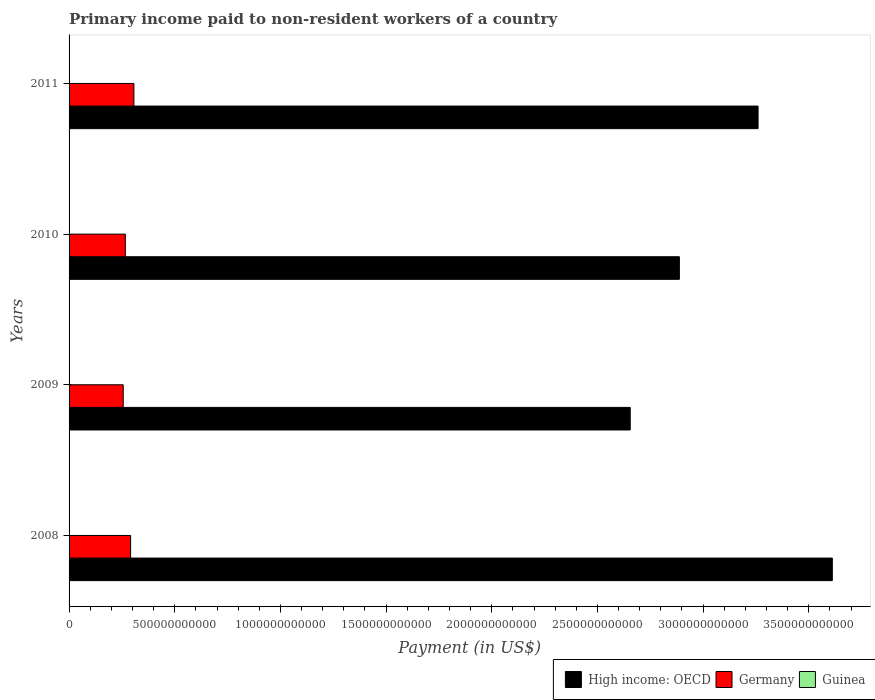How many different coloured bars are there?
Offer a very short reply. 3. How many groups of bars are there?
Offer a terse response. 4. Are the number of bars on each tick of the Y-axis equal?
Your answer should be compact. Yes. What is the label of the 3rd group of bars from the top?
Keep it short and to the point. 2009. What is the amount paid to workers in High income: OECD in 2009?
Your answer should be very brief. 2.66e+12. Across all years, what is the maximum amount paid to workers in High income: OECD?
Your response must be concise. 3.61e+12. Across all years, what is the minimum amount paid to workers in Germany?
Your answer should be very brief. 2.56e+11. What is the total amount paid to workers in Germany in the graph?
Provide a short and direct response. 1.12e+12. What is the difference between the amount paid to workers in Germany in 2010 and that in 2011?
Your answer should be very brief. -4.06e+1. What is the difference between the amount paid to workers in Guinea in 2009 and the amount paid to workers in Germany in 2011?
Make the answer very short. -3.07e+11. What is the average amount paid to workers in Guinea per year?
Your answer should be very brief. 1.73e+07. In the year 2008, what is the difference between the amount paid to workers in Germany and amount paid to workers in High income: OECD?
Offer a very short reply. -3.32e+12. In how many years, is the amount paid to workers in Germany greater than 300000000000 US$?
Offer a terse response. 1. What is the ratio of the amount paid to workers in Guinea in 2008 to that in 2010?
Your answer should be compact. 0.66. Is the amount paid to workers in High income: OECD in 2008 less than that in 2010?
Give a very brief answer. No. What is the difference between the highest and the second highest amount paid to workers in Germany?
Your answer should be very brief. 1.56e+1. What is the difference between the highest and the lowest amount paid to workers in Guinea?
Offer a very short reply. 1.24e+07. Is the sum of the amount paid to workers in Guinea in 2010 and 2011 greater than the maximum amount paid to workers in Germany across all years?
Offer a terse response. No. What does the 1st bar from the top in 2011 represents?
Provide a succinct answer. Guinea. What does the 3rd bar from the bottom in 2010 represents?
Ensure brevity in your answer.  Guinea. Is it the case that in every year, the sum of the amount paid to workers in Germany and amount paid to workers in High income: OECD is greater than the amount paid to workers in Guinea?
Provide a succinct answer. Yes. How many years are there in the graph?
Provide a succinct answer. 4. What is the difference between two consecutive major ticks on the X-axis?
Make the answer very short. 5.00e+11. Are the values on the major ticks of X-axis written in scientific E-notation?
Keep it short and to the point. No. Does the graph contain any zero values?
Offer a terse response. No. Where does the legend appear in the graph?
Provide a succinct answer. Bottom right. How many legend labels are there?
Provide a succinct answer. 3. How are the legend labels stacked?
Your response must be concise. Horizontal. What is the title of the graph?
Offer a terse response. Primary income paid to non-resident workers of a country. What is the label or title of the X-axis?
Provide a succinct answer. Payment (in US$). What is the Payment (in US$) of High income: OECD in 2008?
Provide a short and direct response. 3.61e+12. What is the Payment (in US$) in Germany in 2008?
Your response must be concise. 2.91e+11. What is the Payment (in US$) of Guinea in 2008?
Offer a terse response. 9.85e+06. What is the Payment (in US$) of High income: OECD in 2009?
Provide a succinct answer. 2.66e+12. What is the Payment (in US$) in Germany in 2009?
Make the answer very short. 2.56e+11. What is the Payment (in US$) in Guinea in 2009?
Keep it short and to the point. 2.22e+07. What is the Payment (in US$) of High income: OECD in 2010?
Provide a short and direct response. 2.89e+12. What is the Payment (in US$) in Germany in 2010?
Provide a short and direct response. 2.66e+11. What is the Payment (in US$) of Guinea in 2010?
Provide a short and direct response. 1.49e+07. What is the Payment (in US$) in High income: OECD in 2011?
Make the answer very short. 3.26e+12. What is the Payment (in US$) of Germany in 2011?
Your answer should be compact. 3.07e+11. What is the Payment (in US$) of Guinea in 2011?
Your answer should be compact. 2.22e+07. Across all years, what is the maximum Payment (in US$) of High income: OECD?
Offer a very short reply. 3.61e+12. Across all years, what is the maximum Payment (in US$) of Germany?
Provide a succinct answer. 3.07e+11. Across all years, what is the maximum Payment (in US$) of Guinea?
Your answer should be very brief. 2.22e+07. Across all years, what is the minimum Payment (in US$) in High income: OECD?
Make the answer very short. 2.66e+12. Across all years, what is the minimum Payment (in US$) of Germany?
Offer a terse response. 2.56e+11. Across all years, what is the minimum Payment (in US$) of Guinea?
Keep it short and to the point. 9.85e+06. What is the total Payment (in US$) of High income: OECD in the graph?
Provide a succinct answer. 1.24e+13. What is the total Payment (in US$) of Germany in the graph?
Your response must be concise. 1.12e+12. What is the total Payment (in US$) in Guinea in the graph?
Make the answer very short. 6.92e+07. What is the difference between the Payment (in US$) in High income: OECD in 2008 and that in 2009?
Your response must be concise. 9.56e+11. What is the difference between the Payment (in US$) of Germany in 2008 and that in 2009?
Your answer should be very brief. 3.49e+1. What is the difference between the Payment (in US$) of Guinea in 2008 and that in 2009?
Ensure brevity in your answer.  -1.23e+07. What is the difference between the Payment (in US$) of High income: OECD in 2008 and that in 2010?
Give a very brief answer. 7.24e+11. What is the difference between the Payment (in US$) in Germany in 2008 and that in 2010?
Keep it short and to the point. 2.49e+1. What is the difference between the Payment (in US$) of Guinea in 2008 and that in 2010?
Offer a very short reply. -5.08e+06. What is the difference between the Payment (in US$) of High income: OECD in 2008 and that in 2011?
Your answer should be compact. 3.51e+11. What is the difference between the Payment (in US$) in Germany in 2008 and that in 2011?
Offer a terse response. -1.56e+1. What is the difference between the Payment (in US$) of Guinea in 2008 and that in 2011?
Provide a succinct answer. -1.24e+07. What is the difference between the Payment (in US$) of High income: OECD in 2009 and that in 2010?
Your answer should be compact. -2.33e+11. What is the difference between the Payment (in US$) of Germany in 2009 and that in 2010?
Offer a terse response. -9.98e+09. What is the difference between the Payment (in US$) in Guinea in 2009 and that in 2010?
Ensure brevity in your answer.  7.24e+06. What is the difference between the Payment (in US$) in High income: OECD in 2009 and that in 2011?
Your answer should be very brief. -6.05e+11. What is the difference between the Payment (in US$) in Germany in 2009 and that in 2011?
Provide a short and direct response. -5.06e+1. What is the difference between the Payment (in US$) in High income: OECD in 2010 and that in 2011?
Your response must be concise. -3.72e+11. What is the difference between the Payment (in US$) of Germany in 2010 and that in 2011?
Keep it short and to the point. -4.06e+1. What is the difference between the Payment (in US$) in Guinea in 2010 and that in 2011?
Your response must be concise. -7.31e+06. What is the difference between the Payment (in US$) in High income: OECD in 2008 and the Payment (in US$) in Germany in 2009?
Offer a very short reply. 3.36e+12. What is the difference between the Payment (in US$) of High income: OECD in 2008 and the Payment (in US$) of Guinea in 2009?
Your answer should be compact. 3.61e+12. What is the difference between the Payment (in US$) of Germany in 2008 and the Payment (in US$) of Guinea in 2009?
Offer a terse response. 2.91e+11. What is the difference between the Payment (in US$) of High income: OECD in 2008 and the Payment (in US$) of Germany in 2010?
Your answer should be very brief. 3.35e+12. What is the difference between the Payment (in US$) of High income: OECD in 2008 and the Payment (in US$) of Guinea in 2010?
Provide a short and direct response. 3.61e+12. What is the difference between the Payment (in US$) of Germany in 2008 and the Payment (in US$) of Guinea in 2010?
Offer a very short reply. 2.91e+11. What is the difference between the Payment (in US$) in High income: OECD in 2008 and the Payment (in US$) in Germany in 2011?
Offer a very short reply. 3.30e+12. What is the difference between the Payment (in US$) in High income: OECD in 2008 and the Payment (in US$) in Guinea in 2011?
Your answer should be very brief. 3.61e+12. What is the difference between the Payment (in US$) in Germany in 2008 and the Payment (in US$) in Guinea in 2011?
Offer a terse response. 2.91e+11. What is the difference between the Payment (in US$) in High income: OECD in 2009 and the Payment (in US$) in Germany in 2010?
Ensure brevity in your answer.  2.39e+12. What is the difference between the Payment (in US$) of High income: OECD in 2009 and the Payment (in US$) of Guinea in 2010?
Keep it short and to the point. 2.66e+12. What is the difference between the Payment (in US$) in Germany in 2009 and the Payment (in US$) in Guinea in 2010?
Your response must be concise. 2.56e+11. What is the difference between the Payment (in US$) in High income: OECD in 2009 and the Payment (in US$) in Germany in 2011?
Ensure brevity in your answer.  2.35e+12. What is the difference between the Payment (in US$) of High income: OECD in 2009 and the Payment (in US$) of Guinea in 2011?
Provide a short and direct response. 2.66e+12. What is the difference between the Payment (in US$) in Germany in 2009 and the Payment (in US$) in Guinea in 2011?
Your answer should be compact. 2.56e+11. What is the difference between the Payment (in US$) in High income: OECD in 2010 and the Payment (in US$) in Germany in 2011?
Provide a short and direct response. 2.58e+12. What is the difference between the Payment (in US$) in High income: OECD in 2010 and the Payment (in US$) in Guinea in 2011?
Provide a short and direct response. 2.89e+12. What is the difference between the Payment (in US$) of Germany in 2010 and the Payment (in US$) of Guinea in 2011?
Keep it short and to the point. 2.66e+11. What is the average Payment (in US$) of High income: OECD per year?
Offer a terse response. 3.10e+12. What is the average Payment (in US$) in Germany per year?
Keep it short and to the point. 2.80e+11. What is the average Payment (in US$) of Guinea per year?
Your response must be concise. 1.73e+07. In the year 2008, what is the difference between the Payment (in US$) of High income: OECD and Payment (in US$) of Germany?
Make the answer very short. 3.32e+12. In the year 2008, what is the difference between the Payment (in US$) of High income: OECD and Payment (in US$) of Guinea?
Your answer should be very brief. 3.61e+12. In the year 2008, what is the difference between the Payment (in US$) of Germany and Payment (in US$) of Guinea?
Your response must be concise. 2.91e+11. In the year 2009, what is the difference between the Payment (in US$) in High income: OECD and Payment (in US$) in Germany?
Your answer should be very brief. 2.40e+12. In the year 2009, what is the difference between the Payment (in US$) of High income: OECD and Payment (in US$) of Guinea?
Make the answer very short. 2.66e+12. In the year 2009, what is the difference between the Payment (in US$) of Germany and Payment (in US$) of Guinea?
Your answer should be compact. 2.56e+11. In the year 2010, what is the difference between the Payment (in US$) of High income: OECD and Payment (in US$) of Germany?
Keep it short and to the point. 2.62e+12. In the year 2010, what is the difference between the Payment (in US$) in High income: OECD and Payment (in US$) in Guinea?
Your response must be concise. 2.89e+12. In the year 2010, what is the difference between the Payment (in US$) in Germany and Payment (in US$) in Guinea?
Offer a very short reply. 2.66e+11. In the year 2011, what is the difference between the Payment (in US$) of High income: OECD and Payment (in US$) of Germany?
Keep it short and to the point. 2.95e+12. In the year 2011, what is the difference between the Payment (in US$) of High income: OECD and Payment (in US$) of Guinea?
Your answer should be very brief. 3.26e+12. In the year 2011, what is the difference between the Payment (in US$) in Germany and Payment (in US$) in Guinea?
Provide a succinct answer. 3.07e+11. What is the ratio of the Payment (in US$) in High income: OECD in 2008 to that in 2009?
Ensure brevity in your answer.  1.36. What is the ratio of the Payment (in US$) of Germany in 2008 to that in 2009?
Your answer should be very brief. 1.14. What is the ratio of the Payment (in US$) in Guinea in 2008 to that in 2009?
Provide a succinct answer. 0.44. What is the ratio of the Payment (in US$) in High income: OECD in 2008 to that in 2010?
Make the answer very short. 1.25. What is the ratio of the Payment (in US$) of Germany in 2008 to that in 2010?
Your response must be concise. 1.09. What is the ratio of the Payment (in US$) of Guinea in 2008 to that in 2010?
Provide a succinct answer. 0.66. What is the ratio of the Payment (in US$) in High income: OECD in 2008 to that in 2011?
Offer a very short reply. 1.11. What is the ratio of the Payment (in US$) in Germany in 2008 to that in 2011?
Offer a very short reply. 0.95. What is the ratio of the Payment (in US$) in Guinea in 2008 to that in 2011?
Offer a very short reply. 0.44. What is the ratio of the Payment (in US$) of High income: OECD in 2009 to that in 2010?
Your answer should be very brief. 0.92. What is the ratio of the Payment (in US$) in Germany in 2009 to that in 2010?
Your response must be concise. 0.96. What is the ratio of the Payment (in US$) in Guinea in 2009 to that in 2010?
Give a very brief answer. 1.48. What is the ratio of the Payment (in US$) in High income: OECD in 2009 to that in 2011?
Ensure brevity in your answer.  0.81. What is the ratio of the Payment (in US$) of Germany in 2009 to that in 2011?
Offer a terse response. 0.84. What is the ratio of the Payment (in US$) in High income: OECD in 2010 to that in 2011?
Give a very brief answer. 0.89. What is the ratio of the Payment (in US$) of Germany in 2010 to that in 2011?
Your answer should be compact. 0.87. What is the ratio of the Payment (in US$) of Guinea in 2010 to that in 2011?
Offer a terse response. 0.67. What is the difference between the highest and the second highest Payment (in US$) in High income: OECD?
Ensure brevity in your answer.  3.51e+11. What is the difference between the highest and the second highest Payment (in US$) in Germany?
Provide a short and direct response. 1.56e+1. What is the difference between the highest and the lowest Payment (in US$) of High income: OECD?
Ensure brevity in your answer.  9.56e+11. What is the difference between the highest and the lowest Payment (in US$) in Germany?
Provide a succinct answer. 5.06e+1. What is the difference between the highest and the lowest Payment (in US$) in Guinea?
Offer a terse response. 1.24e+07. 